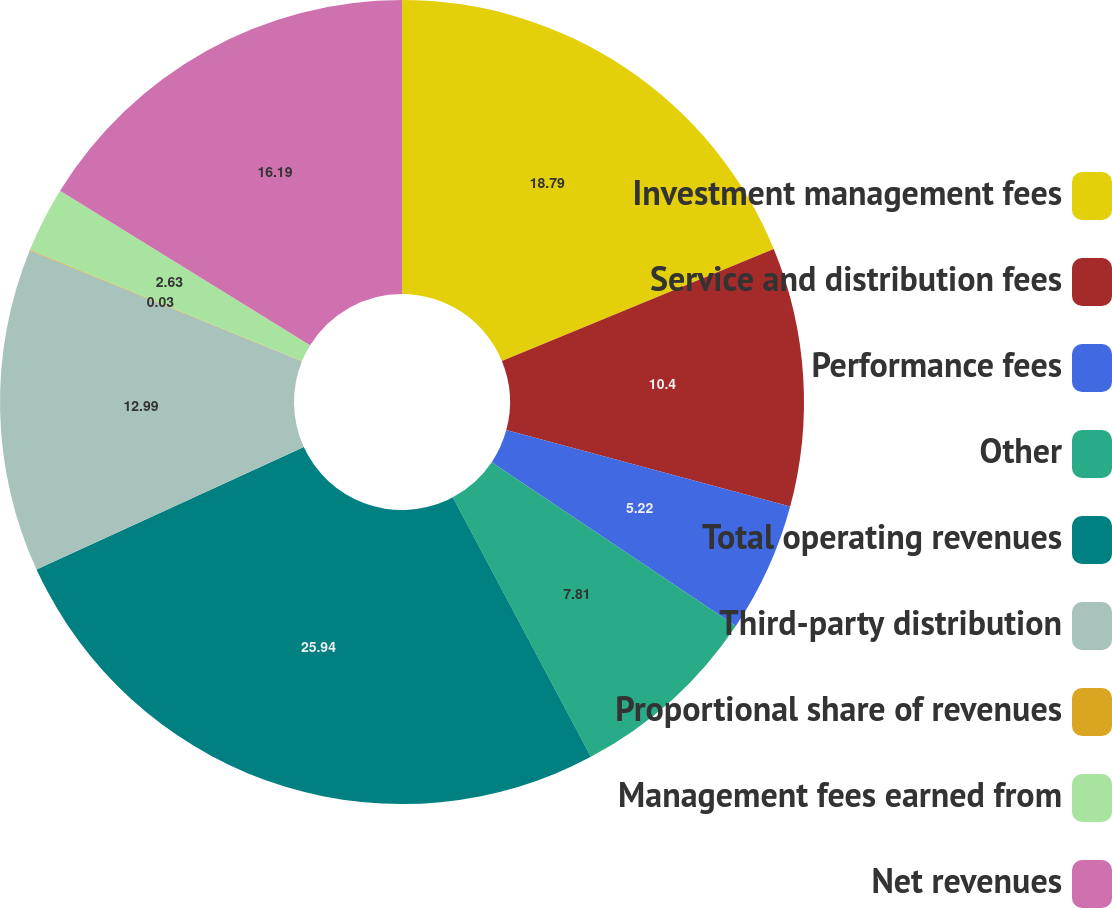Convert chart to OTSL. <chart><loc_0><loc_0><loc_500><loc_500><pie_chart><fcel>Investment management fees<fcel>Service and distribution fees<fcel>Performance fees<fcel>Other<fcel>Total operating revenues<fcel>Third-party distribution<fcel>Proportional share of revenues<fcel>Management fees earned from<fcel>Net revenues<nl><fcel>18.79%<fcel>10.4%<fcel>5.22%<fcel>7.81%<fcel>25.95%<fcel>12.99%<fcel>0.03%<fcel>2.63%<fcel>16.19%<nl></chart> 